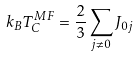Convert formula to latex. <formula><loc_0><loc_0><loc_500><loc_500>k _ { B } T _ { C } ^ { M F } = \frac { 2 } { 3 } \sum _ { j \ne 0 } J _ { 0 j }</formula> 